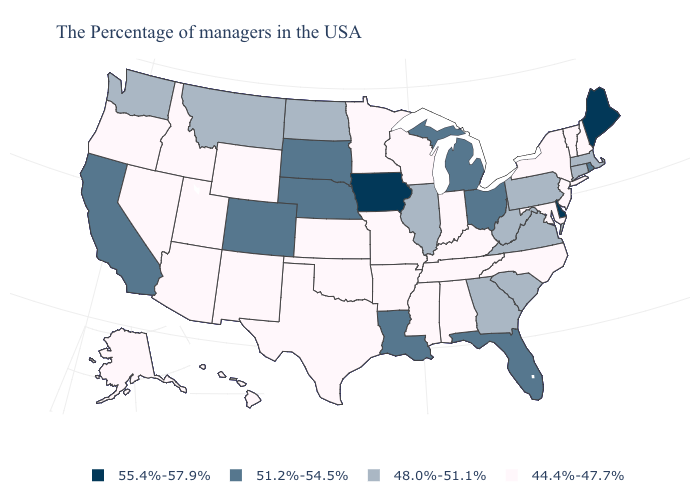Name the states that have a value in the range 51.2%-54.5%?
Give a very brief answer. Rhode Island, Ohio, Florida, Michigan, Louisiana, Nebraska, South Dakota, Colorado, California. What is the value of Vermont?
Quick response, please. 44.4%-47.7%. Among the states that border Alabama , does Mississippi have the lowest value?
Answer briefly. Yes. Which states have the lowest value in the USA?
Be succinct. New Hampshire, Vermont, New York, New Jersey, Maryland, North Carolina, Kentucky, Indiana, Alabama, Tennessee, Wisconsin, Mississippi, Missouri, Arkansas, Minnesota, Kansas, Oklahoma, Texas, Wyoming, New Mexico, Utah, Arizona, Idaho, Nevada, Oregon, Alaska, Hawaii. What is the lowest value in the USA?
Write a very short answer. 44.4%-47.7%. What is the value of Pennsylvania?
Give a very brief answer. 48.0%-51.1%. What is the value of Vermont?
Answer briefly. 44.4%-47.7%. What is the highest value in states that border Wisconsin?
Short answer required. 55.4%-57.9%. Which states have the lowest value in the USA?
Give a very brief answer. New Hampshire, Vermont, New York, New Jersey, Maryland, North Carolina, Kentucky, Indiana, Alabama, Tennessee, Wisconsin, Mississippi, Missouri, Arkansas, Minnesota, Kansas, Oklahoma, Texas, Wyoming, New Mexico, Utah, Arizona, Idaho, Nevada, Oregon, Alaska, Hawaii. Does the first symbol in the legend represent the smallest category?
Keep it brief. No. Which states have the lowest value in the West?
Concise answer only. Wyoming, New Mexico, Utah, Arizona, Idaho, Nevada, Oregon, Alaska, Hawaii. Name the states that have a value in the range 44.4%-47.7%?
Quick response, please. New Hampshire, Vermont, New York, New Jersey, Maryland, North Carolina, Kentucky, Indiana, Alabama, Tennessee, Wisconsin, Mississippi, Missouri, Arkansas, Minnesota, Kansas, Oklahoma, Texas, Wyoming, New Mexico, Utah, Arizona, Idaho, Nevada, Oregon, Alaska, Hawaii. Name the states that have a value in the range 55.4%-57.9%?
Keep it brief. Maine, Delaware, Iowa. Which states have the lowest value in the West?
Be succinct. Wyoming, New Mexico, Utah, Arizona, Idaho, Nevada, Oregon, Alaska, Hawaii. What is the value of Kansas?
Keep it brief. 44.4%-47.7%. 